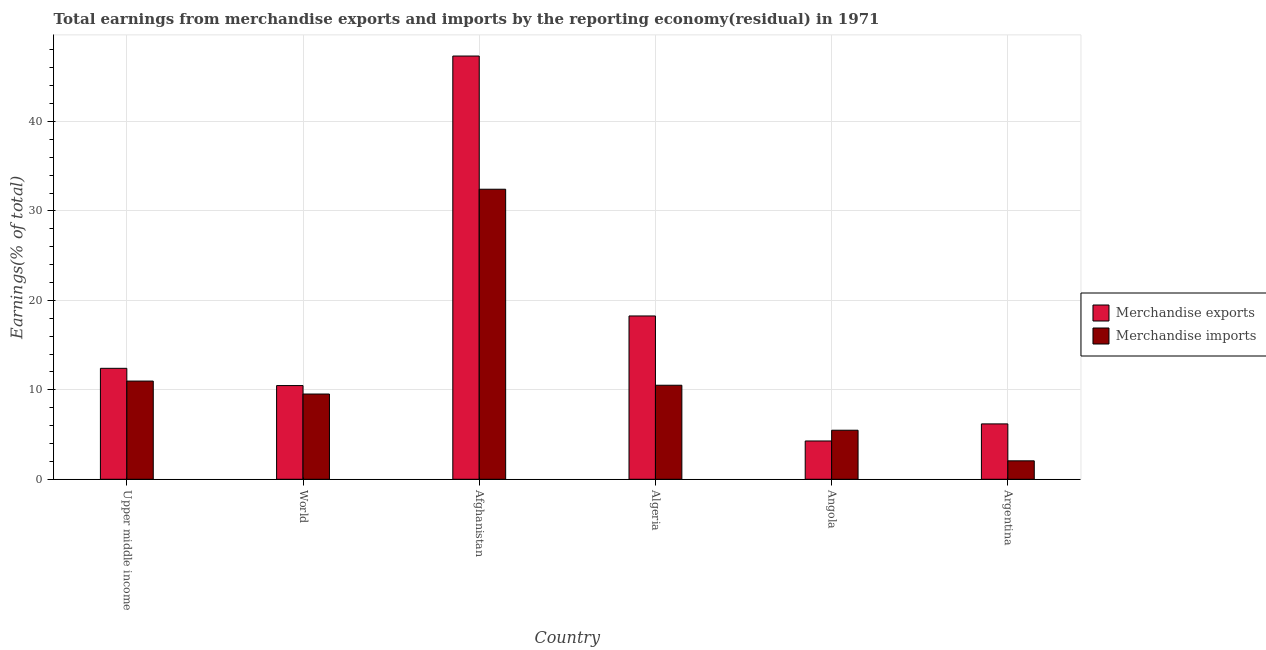How many different coloured bars are there?
Offer a terse response. 2. How many groups of bars are there?
Provide a succinct answer. 6. Are the number of bars on each tick of the X-axis equal?
Provide a short and direct response. Yes. How many bars are there on the 4th tick from the left?
Your response must be concise. 2. What is the label of the 6th group of bars from the left?
Offer a terse response. Argentina. In how many cases, is the number of bars for a given country not equal to the number of legend labels?
Offer a very short reply. 0. What is the earnings from merchandise exports in Argentina?
Your answer should be compact. 6.19. Across all countries, what is the maximum earnings from merchandise imports?
Your answer should be very brief. 32.43. Across all countries, what is the minimum earnings from merchandise exports?
Ensure brevity in your answer.  4.28. In which country was the earnings from merchandise imports maximum?
Offer a very short reply. Afghanistan. In which country was the earnings from merchandise exports minimum?
Your response must be concise. Angola. What is the total earnings from merchandise exports in the graph?
Your answer should be very brief. 98.92. What is the difference between the earnings from merchandise imports in Afghanistan and that in Argentina?
Your answer should be compact. 30.36. What is the difference between the earnings from merchandise exports in Afghanistan and the earnings from merchandise imports in World?
Your response must be concise. 37.78. What is the average earnings from merchandise exports per country?
Provide a short and direct response. 16.49. What is the difference between the earnings from merchandise exports and earnings from merchandise imports in Angola?
Make the answer very short. -1.2. What is the ratio of the earnings from merchandise imports in Angola to that in Upper middle income?
Offer a very short reply. 0.5. Is the earnings from merchandise exports in Afghanistan less than that in Angola?
Give a very brief answer. No. What is the difference between the highest and the second highest earnings from merchandise imports?
Your answer should be very brief. 21.45. What is the difference between the highest and the lowest earnings from merchandise imports?
Provide a succinct answer. 30.36. What does the 1st bar from the left in Algeria represents?
Offer a very short reply. Merchandise exports. What does the 2nd bar from the right in Afghanistan represents?
Your response must be concise. Merchandise exports. How many bars are there?
Provide a short and direct response. 12. How many countries are there in the graph?
Provide a succinct answer. 6. Does the graph contain any zero values?
Your answer should be compact. No. Does the graph contain grids?
Your answer should be very brief. Yes. Where does the legend appear in the graph?
Keep it short and to the point. Center right. How are the legend labels stacked?
Keep it short and to the point. Vertical. What is the title of the graph?
Your answer should be very brief. Total earnings from merchandise exports and imports by the reporting economy(residual) in 1971. What is the label or title of the X-axis?
Your answer should be compact. Country. What is the label or title of the Y-axis?
Make the answer very short. Earnings(% of total). What is the Earnings(% of total) in Merchandise exports in Upper middle income?
Keep it short and to the point. 12.4. What is the Earnings(% of total) of Merchandise imports in Upper middle income?
Offer a very short reply. 10.98. What is the Earnings(% of total) of Merchandise exports in World?
Offer a terse response. 10.48. What is the Earnings(% of total) in Merchandise imports in World?
Provide a short and direct response. 9.53. What is the Earnings(% of total) of Merchandise exports in Afghanistan?
Ensure brevity in your answer.  47.31. What is the Earnings(% of total) of Merchandise imports in Afghanistan?
Offer a terse response. 32.43. What is the Earnings(% of total) in Merchandise exports in Algeria?
Provide a short and direct response. 18.26. What is the Earnings(% of total) in Merchandise imports in Algeria?
Provide a short and direct response. 10.51. What is the Earnings(% of total) in Merchandise exports in Angola?
Provide a short and direct response. 4.28. What is the Earnings(% of total) of Merchandise imports in Angola?
Your answer should be very brief. 5.48. What is the Earnings(% of total) of Merchandise exports in Argentina?
Make the answer very short. 6.19. What is the Earnings(% of total) of Merchandise imports in Argentina?
Offer a very short reply. 2.06. Across all countries, what is the maximum Earnings(% of total) in Merchandise exports?
Provide a succinct answer. 47.31. Across all countries, what is the maximum Earnings(% of total) of Merchandise imports?
Provide a succinct answer. 32.43. Across all countries, what is the minimum Earnings(% of total) of Merchandise exports?
Your response must be concise. 4.28. Across all countries, what is the minimum Earnings(% of total) of Merchandise imports?
Offer a terse response. 2.06. What is the total Earnings(% of total) in Merchandise exports in the graph?
Your answer should be very brief. 98.92. What is the total Earnings(% of total) of Merchandise imports in the graph?
Provide a short and direct response. 70.99. What is the difference between the Earnings(% of total) in Merchandise exports in Upper middle income and that in World?
Make the answer very short. 1.93. What is the difference between the Earnings(% of total) of Merchandise imports in Upper middle income and that in World?
Your answer should be compact. 1.45. What is the difference between the Earnings(% of total) in Merchandise exports in Upper middle income and that in Afghanistan?
Offer a terse response. -34.91. What is the difference between the Earnings(% of total) of Merchandise imports in Upper middle income and that in Afghanistan?
Give a very brief answer. -21.45. What is the difference between the Earnings(% of total) of Merchandise exports in Upper middle income and that in Algeria?
Keep it short and to the point. -5.85. What is the difference between the Earnings(% of total) of Merchandise imports in Upper middle income and that in Algeria?
Keep it short and to the point. 0.47. What is the difference between the Earnings(% of total) of Merchandise exports in Upper middle income and that in Angola?
Make the answer very short. 8.12. What is the difference between the Earnings(% of total) of Merchandise imports in Upper middle income and that in Angola?
Your answer should be compact. 5.5. What is the difference between the Earnings(% of total) in Merchandise exports in Upper middle income and that in Argentina?
Provide a succinct answer. 6.21. What is the difference between the Earnings(% of total) in Merchandise imports in Upper middle income and that in Argentina?
Offer a very short reply. 8.92. What is the difference between the Earnings(% of total) of Merchandise exports in World and that in Afghanistan?
Offer a terse response. -36.84. What is the difference between the Earnings(% of total) of Merchandise imports in World and that in Afghanistan?
Your answer should be very brief. -22.9. What is the difference between the Earnings(% of total) of Merchandise exports in World and that in Algeria?
Ensure brevity in your answer.  -7.78. What is the difference between the Earnings(% of total) of Merchandise imports in World and that in Algeria?
Your response must be concise. -0.98. What is the difference between the Earnings(% of total) of Merchandise exports in World and that in Angola?
Offer a terse response. 6.19. What is the difference between the Earnings(% of total) of Merchandise imports in World and that in Angola?
Offer a terse response. 4.05. What is the difference between the Earnings(% of total) of Merchandise exports in World and that in Argentina?
Offer a very short reply. 4.29. What is the difference between the Earnings(% of total) of Merchandise imports in World and that in Argentina?
Keep it short and to the point. 7.47. What is the difference between the Earnings(% of total) of Merchandise exports in Afghanistan and that in Algeria?
Provide a short and direct response. 29.06. What is the difference between the Earnings(% of total) in Merchandise imports in Afghanistan and that in Algeria?
Give a very brief answer. 21.91. What is the difference between the Earnings(% of total) in Merchandise exports in Afghanistan and that in Angola?
Ensure brevity in your answer.  43.03. What is the difference between the Earnings(% of total) in Merchandise imports in Afghanistan and that in Angola?
Keep it short and to the point. 26.94. What is the difference between the Earnings(% of total) of Merchandise exports in Afghanistan and that in Argentina?
Ensure brevity in your answer.  41.12. What is the difference between the Earnings(% of total) in Merchandise imports in Afghanistan and that in Argentina?
Provide a succinct answer. 30.36. What is the difference between the Earnings(% of total) in Merchandise exports in Algeria and that in Angola?
Offer a very short reply. 13.98. What is the difference between the Earnings(% of total) of Merchandise imports in Algeria and that in Angola?
Your response must be concise. 5.03. What is the difference between the Earnings(% of total) of Merchandise exports in Algeria and that in Argentina?
Ensure brevity in your answer.  12.07. What is the difference between the Earnings(% of total) in Merchandise imports in Algeria and that in Argentina?
Provide a short and direct response. 8.45. What is the difference between the Earnings(% of total) of Merchandise exports in Angola and that in Argentina?
Your answer should be very brief. -1.91. What is the difference between the Earnings(% of total) in Merchandise imports in Angola and that in Argentina?
Offer a very short reply. 3.42. What is the difference between the Earnings(% of total) of Merchandise exports in Upper middle income and the Earnings(% of total) of Merchandise imports in World?
Ensure brevity in your answer.  2.87. What is the difference between the Earnings(% of total) of Merchandise exports in Upper middle income and the Earnings(% of total) of Merchandise imports in Afghanistan?
Your response must be concise. -20.02. What is the difference between the Earnings(% of total) in Merchandise exports in Upper middle income and the Earnings(% of total) in Merchandise imports in Algeria?
Ensure brevity in your answer.  1.89. What is the difference between the Earnings(% of total) in Merchandise exports in Upper middle income and the Earnings(% of total) in Merchandise imports in Angola?
Your response must be concise. 6.92. What is the difference between the Earnings(% of total) in Merchandise exports in Upper middle income and the Earnings(% of total) in Merchandise imports in Argentina?
Your response must be concise. 10.34. What is the difference between the Earnings(% of total) of Merchandise exports in World and the Earnings(% of total) of Merchandise imports in Afghanistan?
Ensure brevity in your answer.  -21.95. What is the difference between the Earnings(% of total) of Merchandise exports in World and the Earnings(% of total) of Merchandise imports in Algeria?
Your answer should be very brief. -0.04. What is the difference between the Earnings(% of total) of Merchandise exports in World and the Earnings(% of total) of Merchandise imports in Angola?
Your answer should be compact. 4.99. What is the difference between the Earnings(% of total) of Merchandise exports in World and the Earnings(% of total) of Merchandise imports in Argentina?
Offer a terse response. 8.41. What is the difference between the Earnings(% of total) of Merchandise exports in Afghanistan and the Earnings(% of total) of Merchandise imports in Algeria?
Provide a succinct answer. 36.8. What is the difference between the Earnings(% of total) of Merchandise exports in Afghanistan and the Earnings(% of total) of Merchandise imports in Angola?
Your response must be concise. 41.83. What is the difference between the Earnings(% of total) of Merchandise exports in Afghanistan and the Earnings(% of total) of Merchandise imports in Argentina?
Provide a short and direct response. 45.25. What is the difference between the Earnings(% of total) of Merchandise exports in Algeria and the Earnings(% of total) of Merchandise imports in Angola?
Offer a very short reply. 12.77. What is the difference between the Earnings(% of total) of Merchandise exports in Algeria and the Earnings(% of total) of Merchandise imports in Argentina?
Your answer should be very brief. 16.19. What is the difference between the Earnings(% of total) in Merchandise exports in Angola and the Earnings(% of total) in Merchandise imports in Argentina?
Keep it short and to the point. 2.22. What is the average Earnings(% of total) in Merchandise exports per country?
Your answer should be compact. 16.49. What is the average Earnings(% of total) of Merchandise imports per country?
Make the answer very short. 11.83. What is the difference between the Earnings(% of total) of Merchandise exports and Earnings(% of total) of Merchandise imports in Upper middle income?
Make the answer very short. 1.42. What is the difference between the Earnings(% of total) in Merchandise exports and Earnings(% of total) in Merchandise imports in World?
Ensure brevity in your answer.  0.95. What is the difference between the Earnings(% of total) in Merchandise exports and Earnings(% of total) in Merchandise imports in Afghanistan?
Keep it short and to the point. 14.89. What is the difference between the Earnings(% of total) in Merchandise exports and Earnings(% of total) in Merchandise imports in Algeria?
Your answer should be compact. 7.74. What is the difference between the Earnings(% of total) of Merchandise exports and Earnings(% of total) of Merchandise imports in Angola?
Your response must be concise. -1.2. What is the difference between the Earnings(% of total) in Merchandise exports and Earnings(% of total) in Merchandise imports in Argentina?
Your answer should be compact. 4.13. What is the ratio of the Earnings(% of total) in Merchandise exports in Upper middle income to that in World?
Make the answer very short. 1.18. What is the ratio of the Earnings(% of total) of Merchandise imports in Upper middle income to that in World?
Offer a terse response. 1.15. What is the ratio of the Earnings(% of total) in Merchandise exports in Upper middle income to that in Afghanistan?
Provide a succinct answer. 0.26. What is the ratio of the Earnings(% of total) in Merchandise imports in Upper middle income to that in Afghanistan?
Provide a succinct answer. 0.34. What is the ratio of the Earnings(% of total) in Merchandise exports in Upper middle income to that in Algeria?
Offer a terse response. 0.68. What is the ratio of the Earnings(% of total) of Merchandise imports in Upper middle income to that in Algeria?
Keep it short and to the point. 1.04. What is the ratio of the Earnings(% of total) of Merchandise exports in Upper middle income to that in Angola?
Offer a terse response. 2.9. What is the ratio of the Earnings(% of total) of Merchandise imports in Upper middle income to that in Angola?
Your answer should be compact. 2. What is the ratio of the Earnings(% of total) of Merchandise exports in Upper middle income to that in Argentina?
Provide a succinct answer. 2. What is the ratio of the Earnings(% of total) of Merchandise imports in Upper middle income to that in Argentina?
Your response must be concise. 5.33. What is the ratio of the Earnings(% of total) in Merchandise exports in World to that in Afghanistan?
Make the answer very short. 0.22. What is the ratio of the Earnings(% of total) in Merchandise imports in World to that in Afghanistan?
Offer a terse response. 0.29. What is the ratio of the Earnings(% of total) of Merchandise exports in World to that in Algeria?
Keep it short and to the point. 0.57. What is the ratio of the Earnings(% of total) of Merchandise imports in World to that in Algeria?
Provide a short and direct response. 0.91. What is the ratio of the Earnings(% of total) in Merchandise exports in World to that in Angola?
Your answer should be compact. 2.45. What is the ratio of the Earnings(% of total) of Merchandise imports in World to that in Angola?
Offer a very short reply. 1.74. What is the ratio of the Earnings(% of total) of Merchandise exports in World to that in Argentina?
Make the answer very short. 1.69. What is the ratio of the Earnings(% of total) in Merchandise imports in World to that in Argentina?
Ensure brevity in your answer.  4.62. What is the ratio of the Earnings(% of total) of Merchandise exports in Afghanistan to that in Algeria?
Offer a terse response. 2.59. What is the ratio of the Earnings(% of total) of Merchandise imports in Afghanistan to that in Algeria?
Make the answer very short. 3.08. What is the ratio of the Earnings(% of total) of Merchandise exports in Afghanistan to that in Angola?
Your answer should be very brief. 11.05. What is the ratio of the Earnings(% of total) of Merchandise imports in Afghanistan to that in Angola?
Your answer should be compact. 5.91. What is the ratio of the Earnings(% of total) of Merchandise exports in Afghanistan to that in Argentina?
Provide a short and direct response. 7.64. What is the ratio of the Earnings(% of total) of Merchandise imports in Afghanistan to that in Argentina?
Offer a very short reply. 15.73. What is the ratio of the Earnings(% of total) of Merchandise exports in Algeria to that in Angola?
Your answer should be compact. 4.26. What is the ratio of the Earnings(% of total) in Merchandise imports in Algeria to that in Angola?
Keep it short and to the point. 1.92. What is the ratio of the Earnings(% of total) of Merchandise exports in Algeria to that in Argentina?
Your answer should be compact. 2.95. What is the ratio of the Earnings(% of total) in Merchandise imports in Algeria to that in Argentina?
Your response must be concise. 5.1. What is the ratio of the Earnings(% of total) of Merchandise exports in Angola to that in Argentina?
Your response must be concise. 0.69. What is the ratio of the Earnings(% of total) of Merchandise imports in Angola to that in Argentina?
Offer a very short reply. 2.66. What is the difference between the highest and the second highest Earnings(% of total) of Merchandise exports?
Your answer should be compact. 29.06. What is the difference between the highest and the second highest Earnings(% of total) in Merchandise imports?
Your answer should be very brief. 21.45. What is the difference between the highest and the lowest Earnings(% of total) of Merchandise exports?
Offer a very short reply. 43.03. What is the difference between the highest and the lowest Earnings(% of total) of Merchandise imports?
Your answer should be very brief. 30.36. 